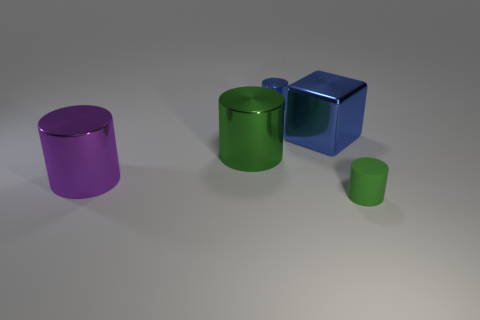Is there anything else that has the same material as the small green cylinder?
Give a very brief answer. No. How many purple cylinders are behind the blue object in front of the small cylinder that is behind the cube?
Offer a terse response. 0. What size is the other object that is the same color as the rubber object?
Ensure brevity in your answer.  Large. Are there any large blocks that have the same material as the purple cylinder?
Make the answer very short. Yes. Is the material of the purple cylinder the same as the blue cylinder?
Your answer should be very brief. Yes. How many tiny objects are behind the green thing that is behind the purple metallic cylinder?
Ensure brevity in your answer.  1. How many blue things are either big matte cubes or blocks?
Offer a very short reply. 1. What is the shape of the small thing to the right of the metal cylinder that is behind the blue shiny block that is in front of the tiny shiny thing?
Ensure brevity in your answer.  Cylinder. There is a cylinder that is the same size as the purple thing; what color is it?
Your response must be concise. Green. How many large blue metallic things are the same shape as the small green matte object?
Your response must be concise. 0. 